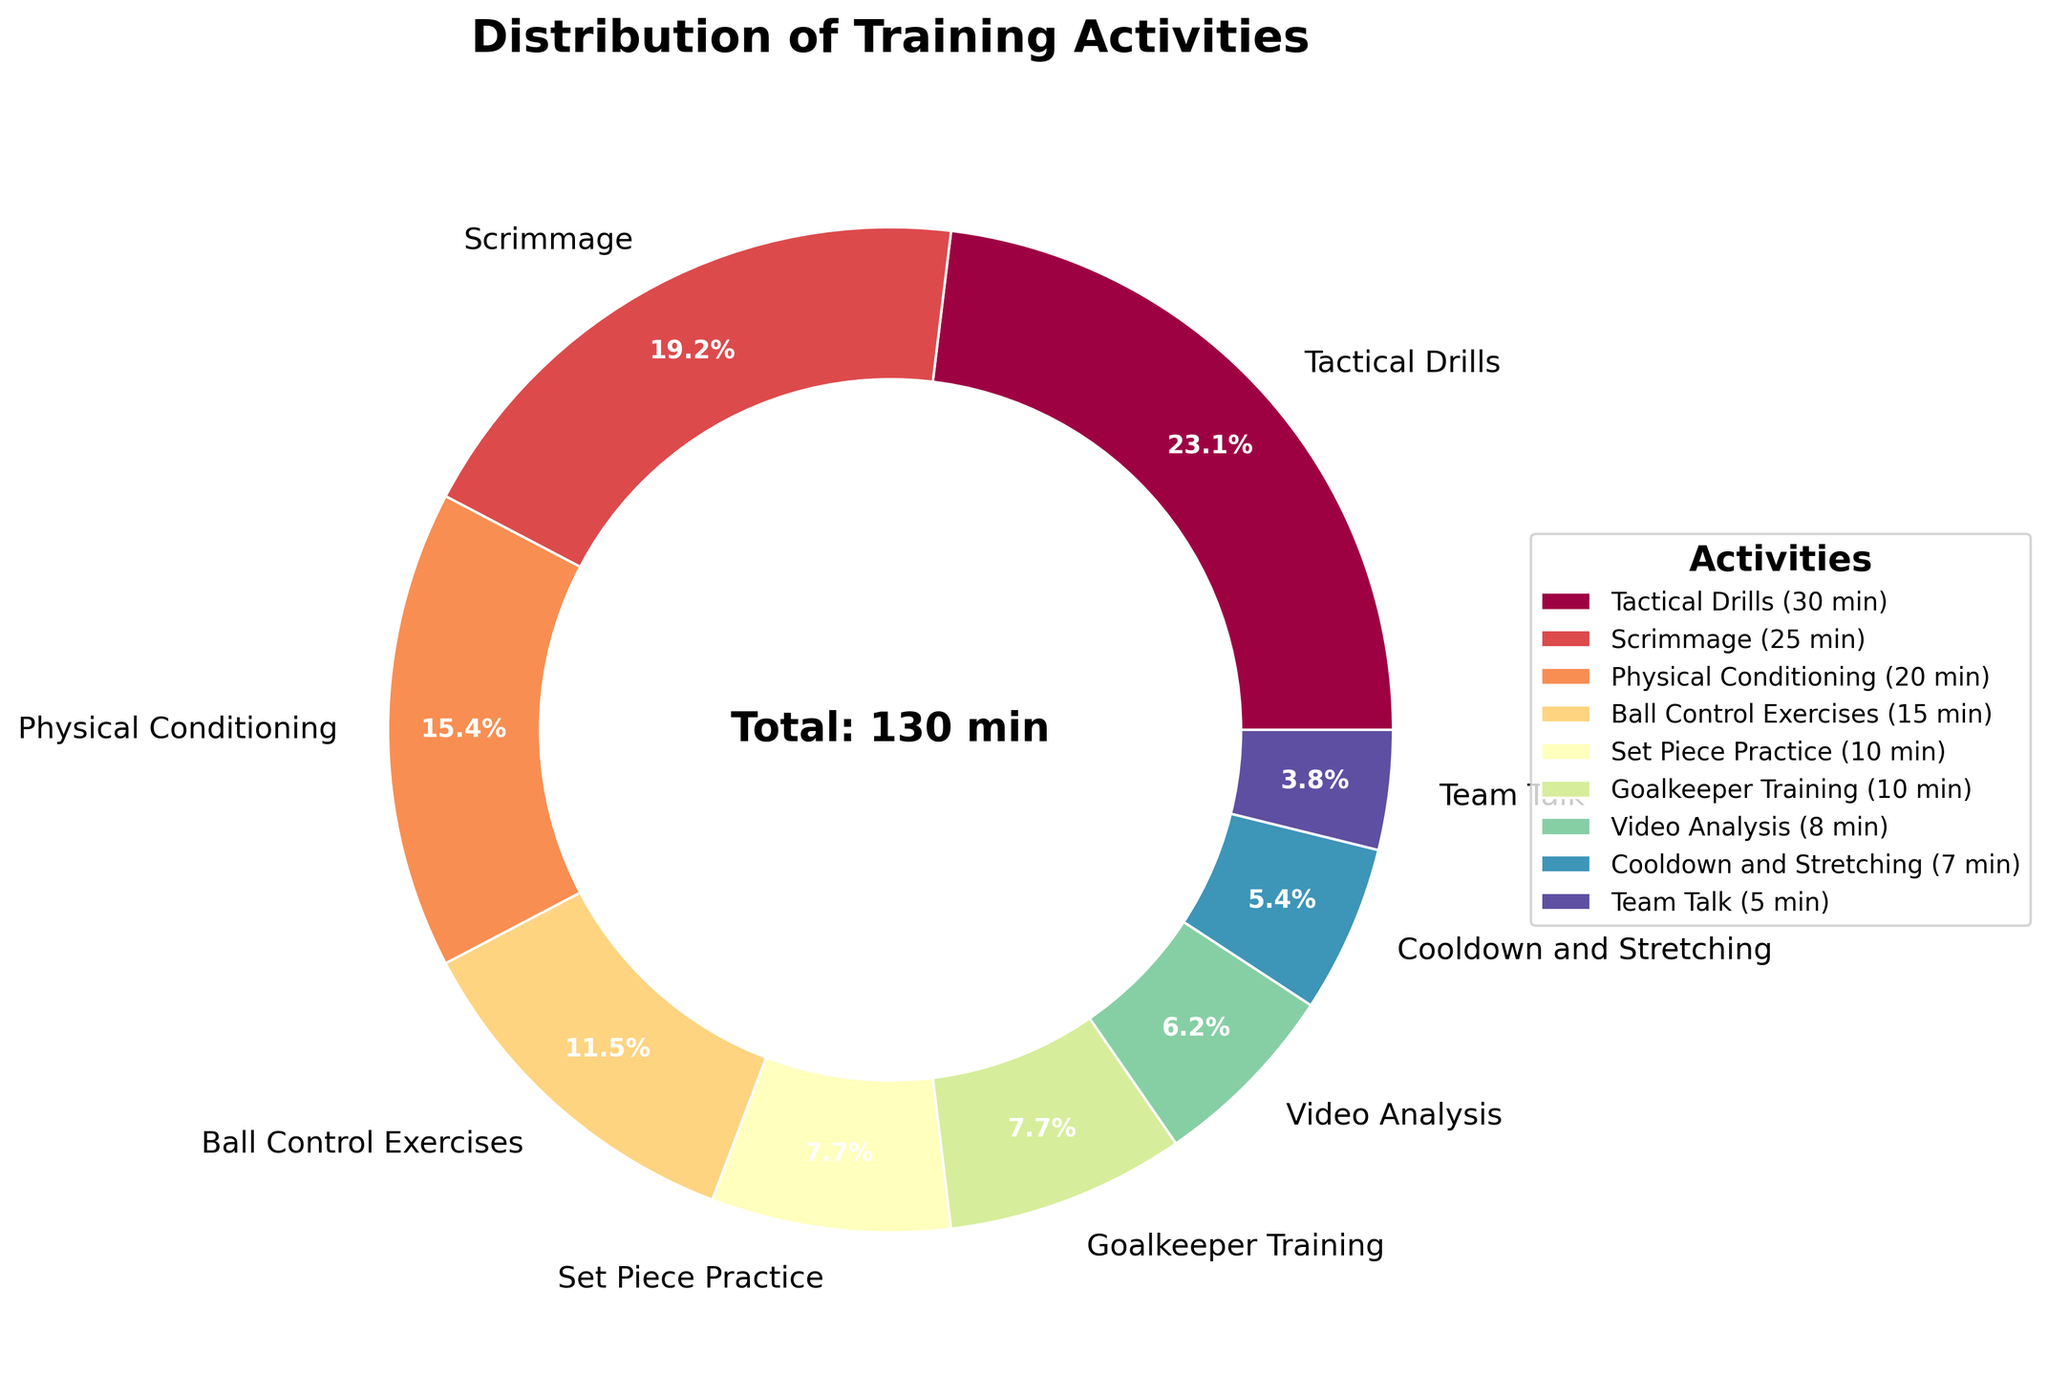Which activity takes up the most time? The wedge representing "Tactical Drills" in the pie chart is the largest, indicating it occupies the most time during training.
Answer: Tactical Drills How much time is spent on Goalkeeper Training and Set Piece Practice combined? The data shows that 10 minutes are dedicated to Goalkeeper Training and 10 minutes to Set Piece Practice. Adding these together gives a total of 20 minutes.
Answer: 20 minutes Which activity has the smallest proportion of time? The smallest wedge in the pie chart represents "Team Talk," making it the activity with the least time spent.
Answer: Team Talk Is more time spent on Scrimmage or Physical Conditioning? By comparing the sizes of the wedges in the pie chart, it is clear that "Scrimmage" (25 minutes) occupies a larger portion than "Physical Conditioning" (20 minutes).
Answer: Scrimmage Calculate the percentage of time spent on Ball Control Exercises relative to the total session time. The total time of all activities is 130 minutes. "Ball Control Exercises" takes 15 minutes. The percentage is calculated by (15 / 130) * 100 ≈ 11.5%.
Answer: 11.5% Compare the combined time spent on Video Analysis and Cooldown and Stretching to Ball Control Exercises. Video Analysis takes 8 minutes, and Cooldown and Stretching takes 7 minutes. Combined, they total 15 minutes, which is equal to the 15 minutes spent on Ball Control Exercises.
Answer: Equal Which activity related to technique or skills (not physical conditioning) takes the least time? Among "Ball Control Exercises," "Set Piece Practice," and "Goalkeeper Training," the activity with the smallest wedge in the pie chart is "Team Talk," but that is not technique or skills-related. Among the relevant categories, "Set Piece Practice" (10 minutes) has the least time.
Answer: Set Piece Practice What fraction of the session is spent on Set Piece Practice and Goalkeeper Training combined? The total session time is 130 minutes. Combined time for Set Piece Practice and Goalkeeper Training is 20 minutes (10 + 10). The fraction is 20/130, which simplifies to approximately 2/13.
Answer: 2/13 Compare the time spent on Video Analysis to the time spent on Team Talk. Which is more? By observing the sizes of the wedges for "Video Analysis" (8 minutes) and "Team Talk" (5 minutes), it is clear that more time is spent on Video Analysis.
Answer: Video Analysis 